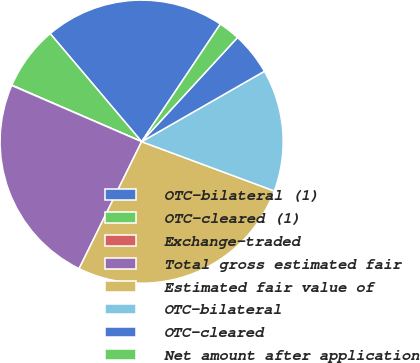Convert chart. <chart><loc_0><loc_0><loc_500><loc_500><pie_chart><fcel>OTC-bilateral (1)<fcel>OTC-cleared (1)<fcel>Exchange-traded<fcel>Total gross estimated fair<fcel>Estimated fair value of<fcel>OTC-bilateral<fcel>OTC-cleared<fcel>Net amount after application<nl><fcel>20.57%<fcel>7.29%<fcel>0.04%<fcel>24.21%<fcel>26.62%<fcel>13.95%<fcel>4.87%<fcel>2.45%<nl></chart> 